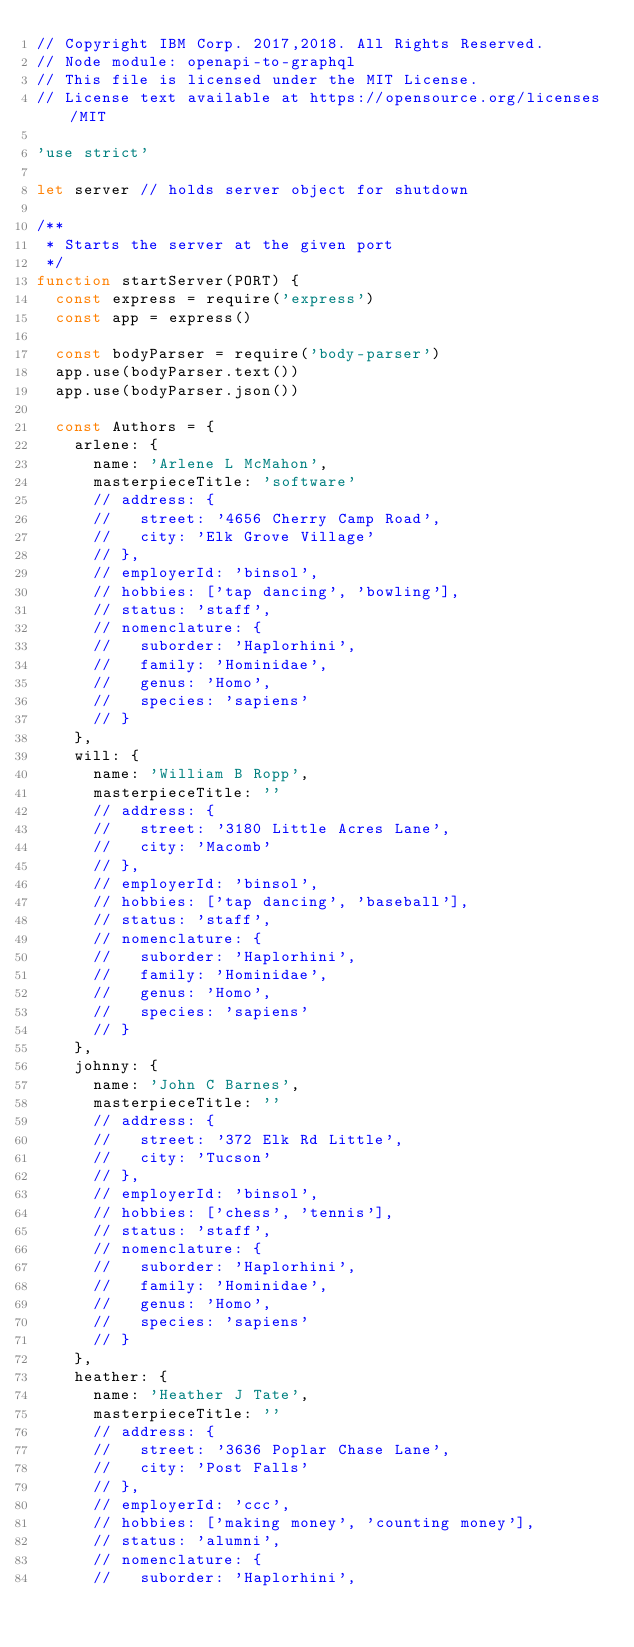Convert code to text. <code><loc_0><loc_0><loc_500><loc_500><_JavaScript_>// Copyright IBM Corp. 2017,2018. All Rights Reserved.
// Node module: openapi-to-graphql
// This file is licensed under the MIT License.
// License text available at https://opensource.org/licenses/MIT

'use strict'

let server // holds server object for shutdown

/**
 * Starts the server at the given port
 */
function startServer(PORT) {
  const express = require('express')
  const app = express()

  const bodyParser = require('body-parser')
  app.use(bodyParser.text())
  app.use(bodyParser.json())

  const Authors = {
    arlene: {
      name: 'Arlene L McMahon',
      masterpieceTitle: 'software'
      // address: {
      //   street: '4656 Cherry Camp Road',
      //   city: 'Elk Grove Village'
      // },
      // employerId: 'binsol',
      // hobbies: ['tap dancing', 'bowling'],
      // status: 'staff',
      // nomenclature: {
      //   suborder: 'Haplorhini',
      //   family: 'Hominidae',
      //   genus: 'Homo',
      //   species: 'sapiens'
      // }
    },
    will: {
      name: 'William B Ropp',
      masterpieceTitle: ''
      // address: {
      //   street: '3180 Little Acres Lane',
      //   city: 'Macomb'
      // },
      // employerId: 'binsol',
      // hobbies: ['tap dancing', 'baseball'],
      // status: 'staff',
      // nomenclature: {
      //   suborder: 'Haplorhini',
      //   family: 'Hominidae',
      //   genus: 'Homo',
      //   species: 'sapiens'
      // }
    },
    johnny: {
      name: 'John C Barnes',
      masterpieceTitle: ''
      // address: {
      //   street: '372 Elk Rd Little',
      //   city: 'Tucson'
      // },
      // employerId: 'binsol',
      // hobbies: ['chess', 'tennis'],
      // status: 'staff',
      // nomenclature: {
      //   suborder: 'Haplorhini',
      //   family: 'Hominidae',
      //   genus: 'Homo',
      //   species: 'sapiens'
      // }
    },
    heather: {
      name: 'Heather J Tate',
      masterpieceTitle: ''
      // address: {
      //   street: '3636 Poplar Chase Lane',
      //   city: 'Post Falls'
      // },
      // employerId: 'ccc',
      // hobbies: ['making money', 'counting money'],
      // status: 'alumni',
      // nomenclature: {
      //   suborder: 'Haplorhini',</code> 